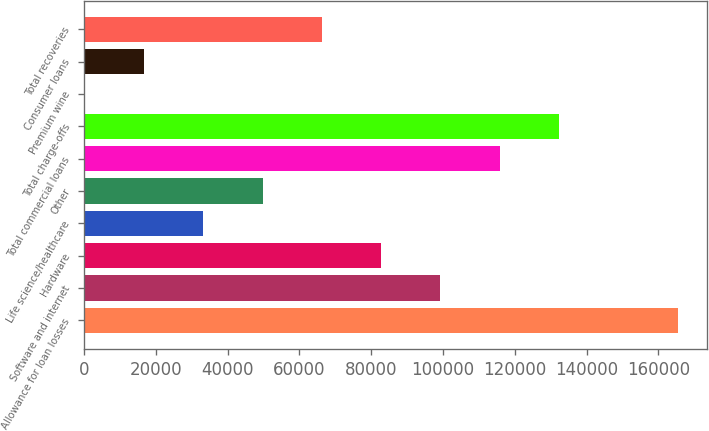Convert chart to OTSL. <chart><loc_0><loc_0><loc_500><loc_500><bar_chart><fcel>Allowance for loan losses<fcel>Software and internet<fcel>Hardware<fcel>Life science/healthcare<fcel>Other<fcel>Total commercial loans<fcel>Total charge-offs<fcel>Premium wine<fcel>Consumer loans<fcel>Total recoveries<nl><fcel>165359<fcel>99311.4<fcel>82799.5<fcel>33263.8<fcel>49775.7<fcel>115823<fcel>132335<fcel>240<fcel>16751.9<fcel>66287.6<nl></chart> 